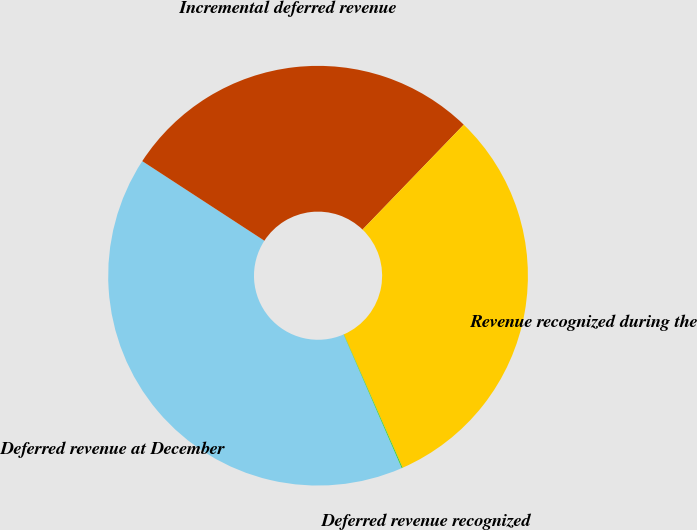<chart> <loc_0><loc_0><loc_500><loc_500><pie_chart><fcel>Deferred revenue at December<fcel>Incremental deferred revenue<fcel>Revenue recognized during the<fcel>Deferred revenue recognized<nl><fcel>40.72%<fcel>28.02%<fcel>31.19%<fcel>0.07%<nl></chart> 